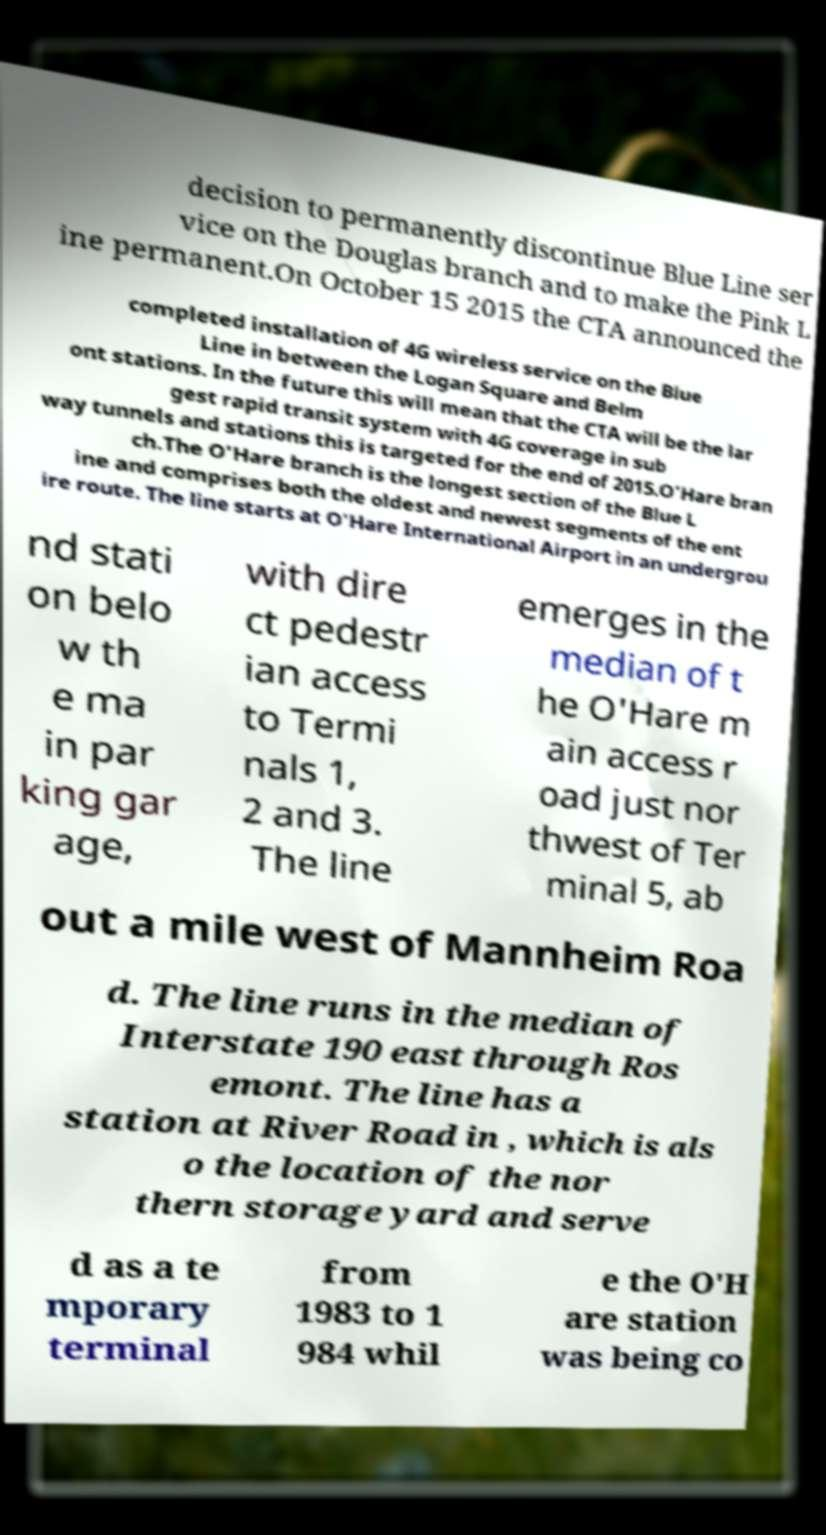What messages or text are displayed in this image? I need them in a readable, typed format. decision to permanently discontinue Blue Line ser vice on the Douglas branch and to make the Pink L ine permanent.On October 15 2015 the CTA announced the completed installation of 4G wireless service on the Blue Line in between the Logan Square and Belm ont stations. In the future this will mean that the CTA will be the lar gest rapid transit system with 4G coverage in sub way tunnels and stations this is targeted for the end of 2015.O'Hare bran ch.The O'Hare branch is the longest section of the Blue L ine and comprises both the oldest and newest segments of the ent ire route. The line starts at O'Hare International Airport in an undergrou nd stati on belo w th e ma in par king gar age, with dire ct pedestr ian access to Termi nals 1, 2 and 3. The line emerges in the median of t he O'Hare m ain access r oad just nor thwest of Ter minal 5, ab out a mile west of Mannheim Roa d. The line runs in the median of Interstate 190 east through Ros emont. The line has a station at River Road in , which is als o the location of the nor thern storage yard and serve d as a te mporary terminal from 1983 to 1 984 whil e the O'H are station was being co 